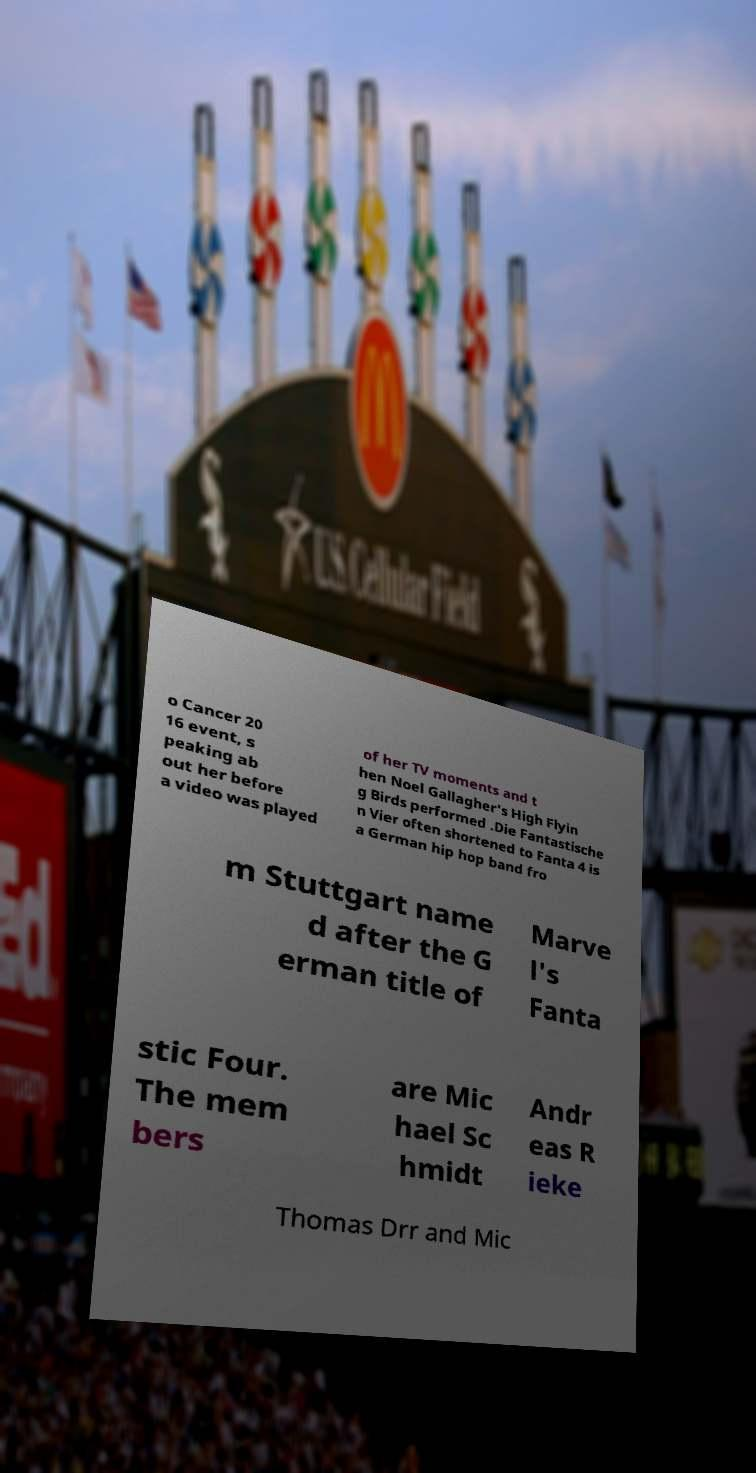Could you extract and type out the text from this image? o Cancer 20 16 event, s peaking ab out her before a video was played of her TV moments and t hen Noel Gallagher's High Flyin g Birds performed .Die Fantastische n Vier often shortened to Fanta 4 is a German hip hop band fro m Stuttgart name d after the G erman title of Marve l's Fanta stic Four. The mem bers are Mic hael Sc hmidt Andr eas R ieke Thomas Drr and Mic 